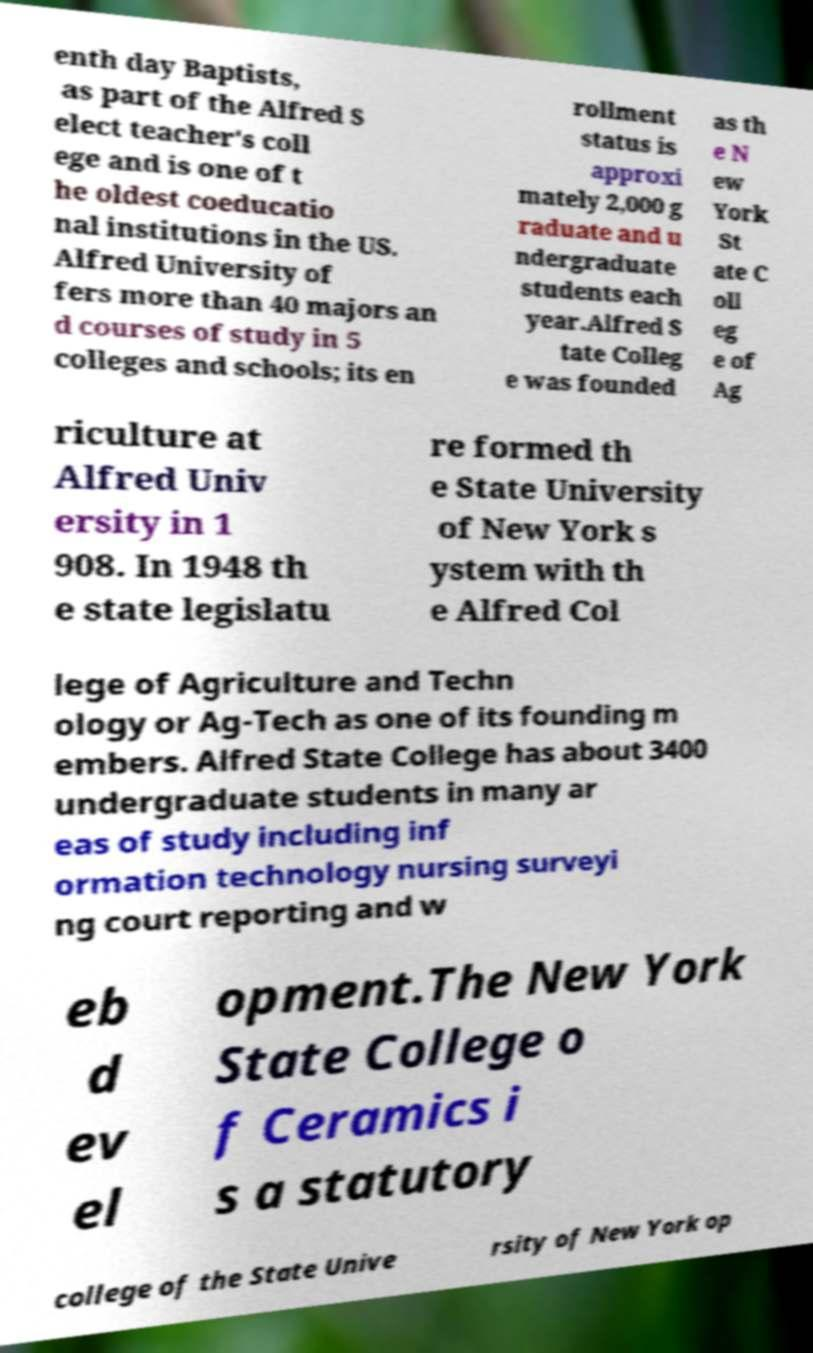I need the written content from this picture converted into text. Can you do that? enth day Baptists, as part of the Alfred S elect teacher's coll ege and is one of t he oldest coeducatio nal institutions in the US. Alfred University of fers more than 40 majors an d courses of study in 5 colleges and schools; its en rollment status is approxi mately 2,000 g raduate and u ndergraduate students each year.Alfred S tate Colleg e was founded as th e N ew York St ate C oll eg e of Ag riculture at Alfred Univ ersity in 1 908. In 1948 th e state legislatu re formed th e State University of New York s ystem with th e Alfred Col lege of Agriculture and Techn ology or Ag-Tech as one of its founding m embers. Alfred State College has about 3400 undergraduate students in many ar eas of study including inf ormation technology nursing surveyi ng court reporting and w eb d ev el opment.The New York State College o f Ceramics i s a statutory college of the State Unive rsity of New York op 